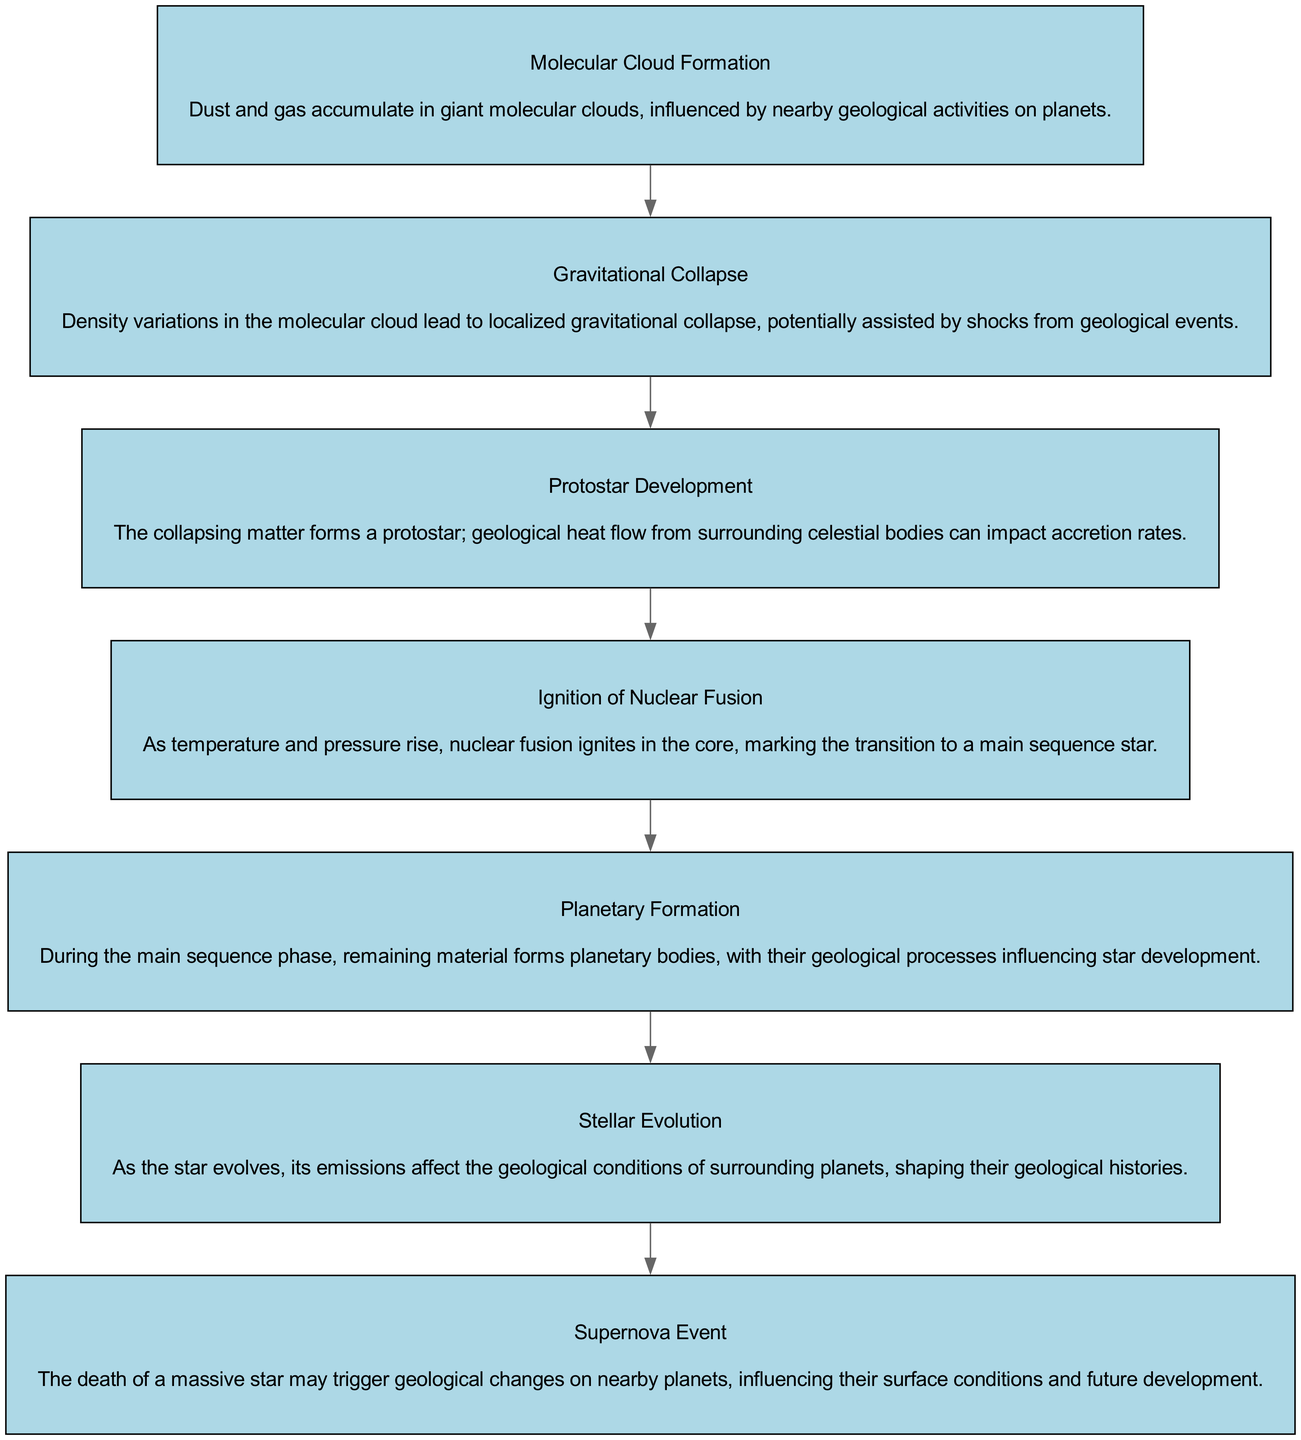What is the first stage in the diagram? The first stage in the diagram is "Molecular Cloud Formation," which is explicitly stated as the starting point of the flow.
Answer: Molecular Cloud Formation How many stages are displayed in the diagram? The diagram contains 7 stages, as listed sequentially in the provided data.
Answer: 7 Which stage directly follows "Gravitational Collapse"? The stage that directly follows "Gravitational Collapse" is "Protostar Development," which is indicated by the connecting arrow in the flow chart.
Answer: Protostar Development What is influenced by geological activities in the first stage? The first stage indicates that dust and gas accumulation in molecular clouds is influenced by "nearby geological activities on planets."
Answer: Nearby geological activities on planets During which stage does nuclear fusion ignite? Nuclear fusion ignites during the "Ignition of Nuclear Fusion" stage, highlighted as a key transition point in the development process of a star.
Answer: Ignition of Nuclear Fusion What is the last stage before a supernova event? The last stage before the supernova event is "Stellar Evolution," as it occurs in the sequence right before the death of a massive star.
Answer: Stellar Evolution How does planetary formation relate to the main sequence phase? During the main sequence phase, the remaining material forms planetary bodies, which indicates a strong connection between planetary formation and the geological processes.
Answer: Forms planetary bodies What may trigger geological changes on nearby planets? A "Supernova Event" may trigger geological changes on nearby planets, indicating the impact of stellar death on planetary geology.
Answer: Supernova Event 